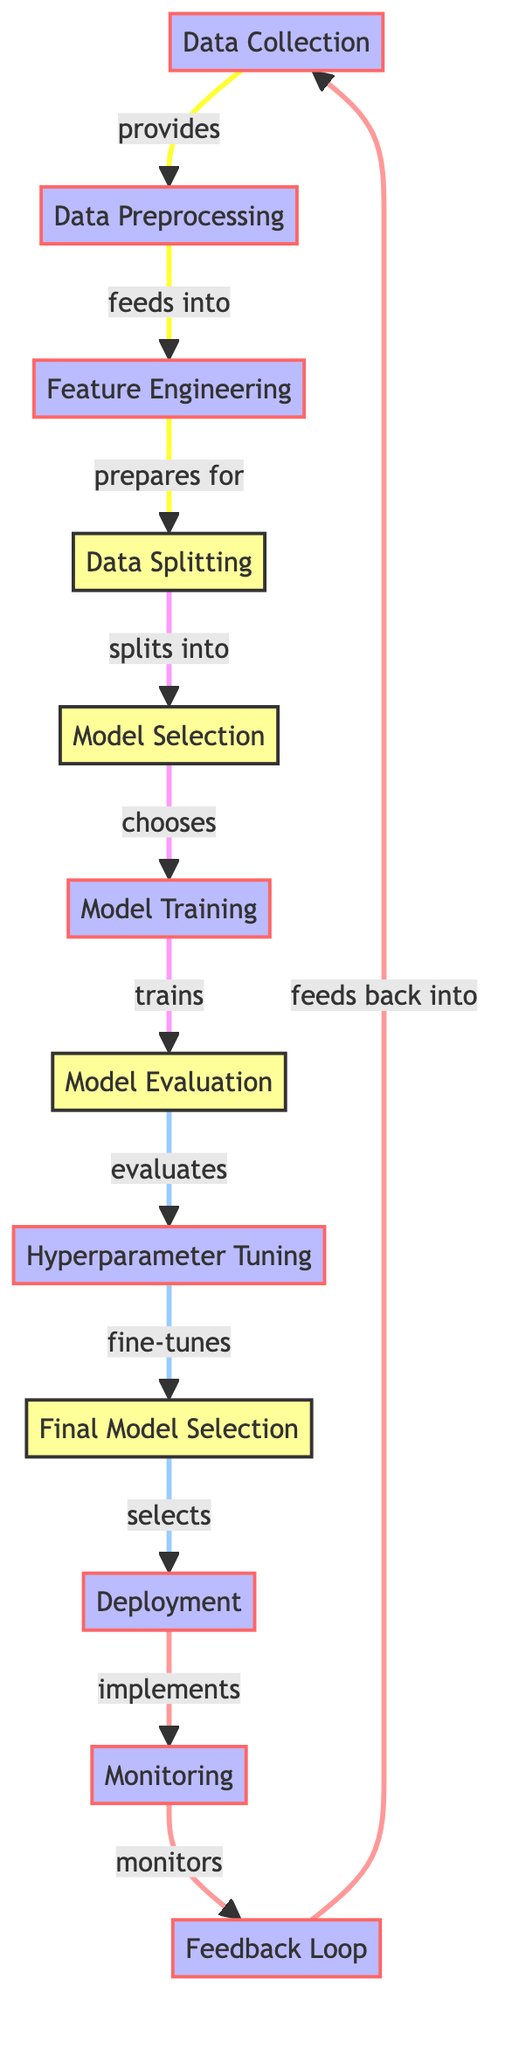What is the starting point of the workflow? The workflow begins with the node labeled "Data Collection," which is the first step in the process.
Answer: Data Collection How many main processes are in the workflow? There are ten main processes in the workflow, including Data Collection and Monitoring.
Answer: 10 Which node precedes Model Training? The node that comes directly before Model Training is Model Selection, indicating the order of operations leading to training the model.
Answer: Model Selection What relationship exists between Hyperparameter Tuning and Final Model Selection? Hyperparameter Tuning feeds into Final Model Selection, as it involves fine-tuning the model before the final selection is made.
Answer: feeds into How does the workflow handle feedback after deployment? The workflow incorporates a Feedback Loop that takes insights and information from Monitoring back to Data Collection, creating a cyclic process for improvement.
Answer: Feedback Loop Which nodes are involved in the process of feature engineering? The nodes involved in the process of feature engineering are Data Preprocessing and Feature Engineering, which contribute to preparing the data for modeling.
Answer: Data Preprocessing, Feature Engineering What is the final node of the workflow? The last node in the workflow is Monitoring, which is part of the continuous process of evaluating the performance of the deployed model.
Answer: Monitoring How many decision nodes are present in the diagram? There are four decision nodes in the workflow: Data Splitting, Model Selection, Model Evaluation, and Final Model Selection.
Answer: 4 What action follows Deployment in the workflow? The action that follows Deployment is Monitoring, indicating the next steps after the application of the developed model.
Answer: Monitoring What does the arrow from Feedback Loop point to? The arrow from Feedback Loop points back to Data Collection, indicating a cyclical process of incorporating feedback into data gathering.
Answer: Data Collection 